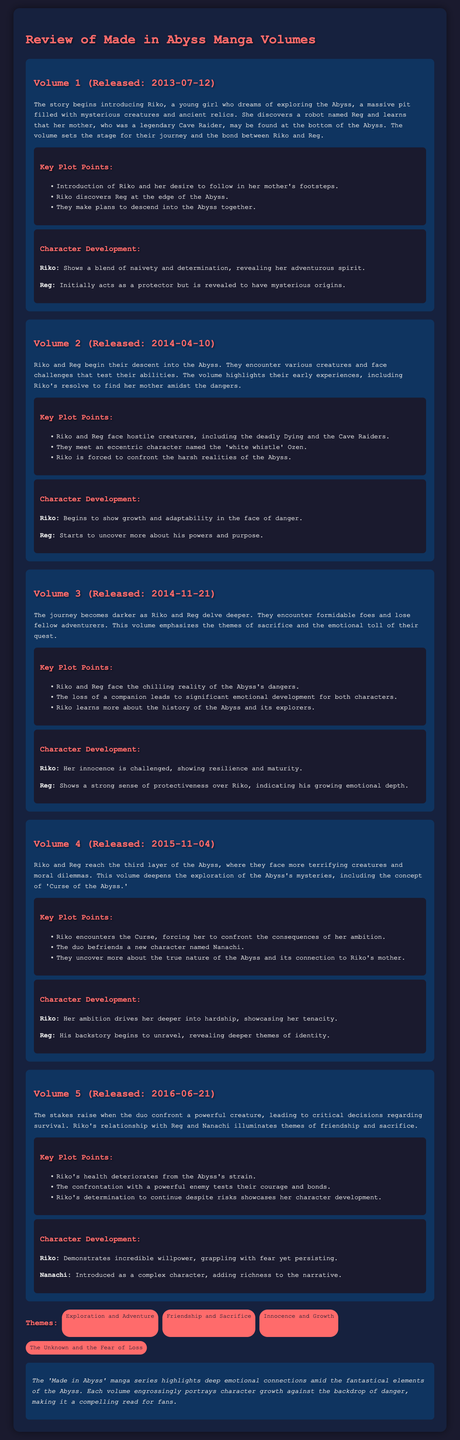what is the title of the document? The title is prominently displayed at the top of the document.
Answer: Review of Made in Abyss Manga Volumes who is the main character introduced in Volume 1? The document explicitly names the main character introduced in Volume 1.
Answer: Riko when was Volume 3 released? The release date for Volume 3 is provided in the document.
Answer: 2014-11-21 what creature do Riko and Reg confront in Volume 5? The document mentions a powerful creature faced in Volume 5.
Answer: Powerful enemy which character is described as having mysterious origins? The document specifically mentions a character with mysterious origins in Volume 1.
Answer: Reg how many volumes are reviewed in the document? The document contains a section that lists the number of volumes reviewed.
Answer: Five what theme is highlighted alongside friendship and sacrifice? The themes of the document are listed, including one mentioned in the question.
Answer: Innocence and Growth which new character do Riko and Reg befriend in Volume 4? The document clearly states the new character they befriend in Volume 4.
Answer: Nanachi what emotional aspect is emphasized in Volume 3? The document outlines the emotional aspects and themes present in Volume 3.
Answer: Sacrifice 